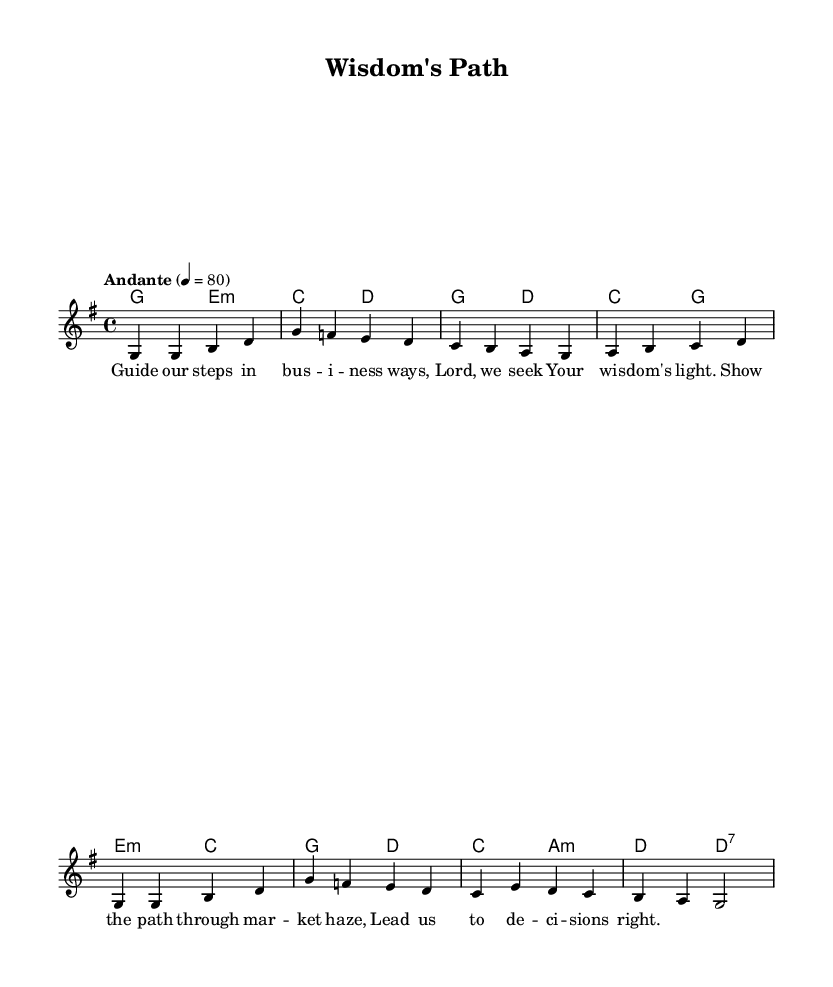What is the key signature of this music? The key signature indicates G major, which has one sharp (F#). This can be identified by looking at the key signature at the beginning of the staff.
Answer: G major What is the time signature of this music? The time signature is shown at the beginning of the score as 4/4, which indicates four beats per measure and a quarter note gets one beat.
Answer: 4/4 What is the tempo marking for this piece? The tempo marking is "Andante" which can be found above the staff in the tempo section, indicating a moderate pace.
Answer: Andante How many measures are in the melody? By counting the number of vertical lines (bars) separating the notes, there are a total of eight measures in the melody section.
Answer: Eight Which chord is played on the first beat of the first measure? The first beat of the first measure indicates a G major chord, identified by the chord symbols written above the staff at the start.
Answer: G major What is the overall theme of the lyrics? The lyrics express a plea for divine guidance in making wise business decisions, focusing on seeking wisdom and enlightenment amid challenges.
Answer: Divine guidance What type of harmony is featured in the harmonies section? The harmonies primarily consist of major and minor chords, with frequent use of major chords such as G major, C major, and E minor, indicating a traditional harmonic structure typical in hymns.
Answer: Major and minor chords 